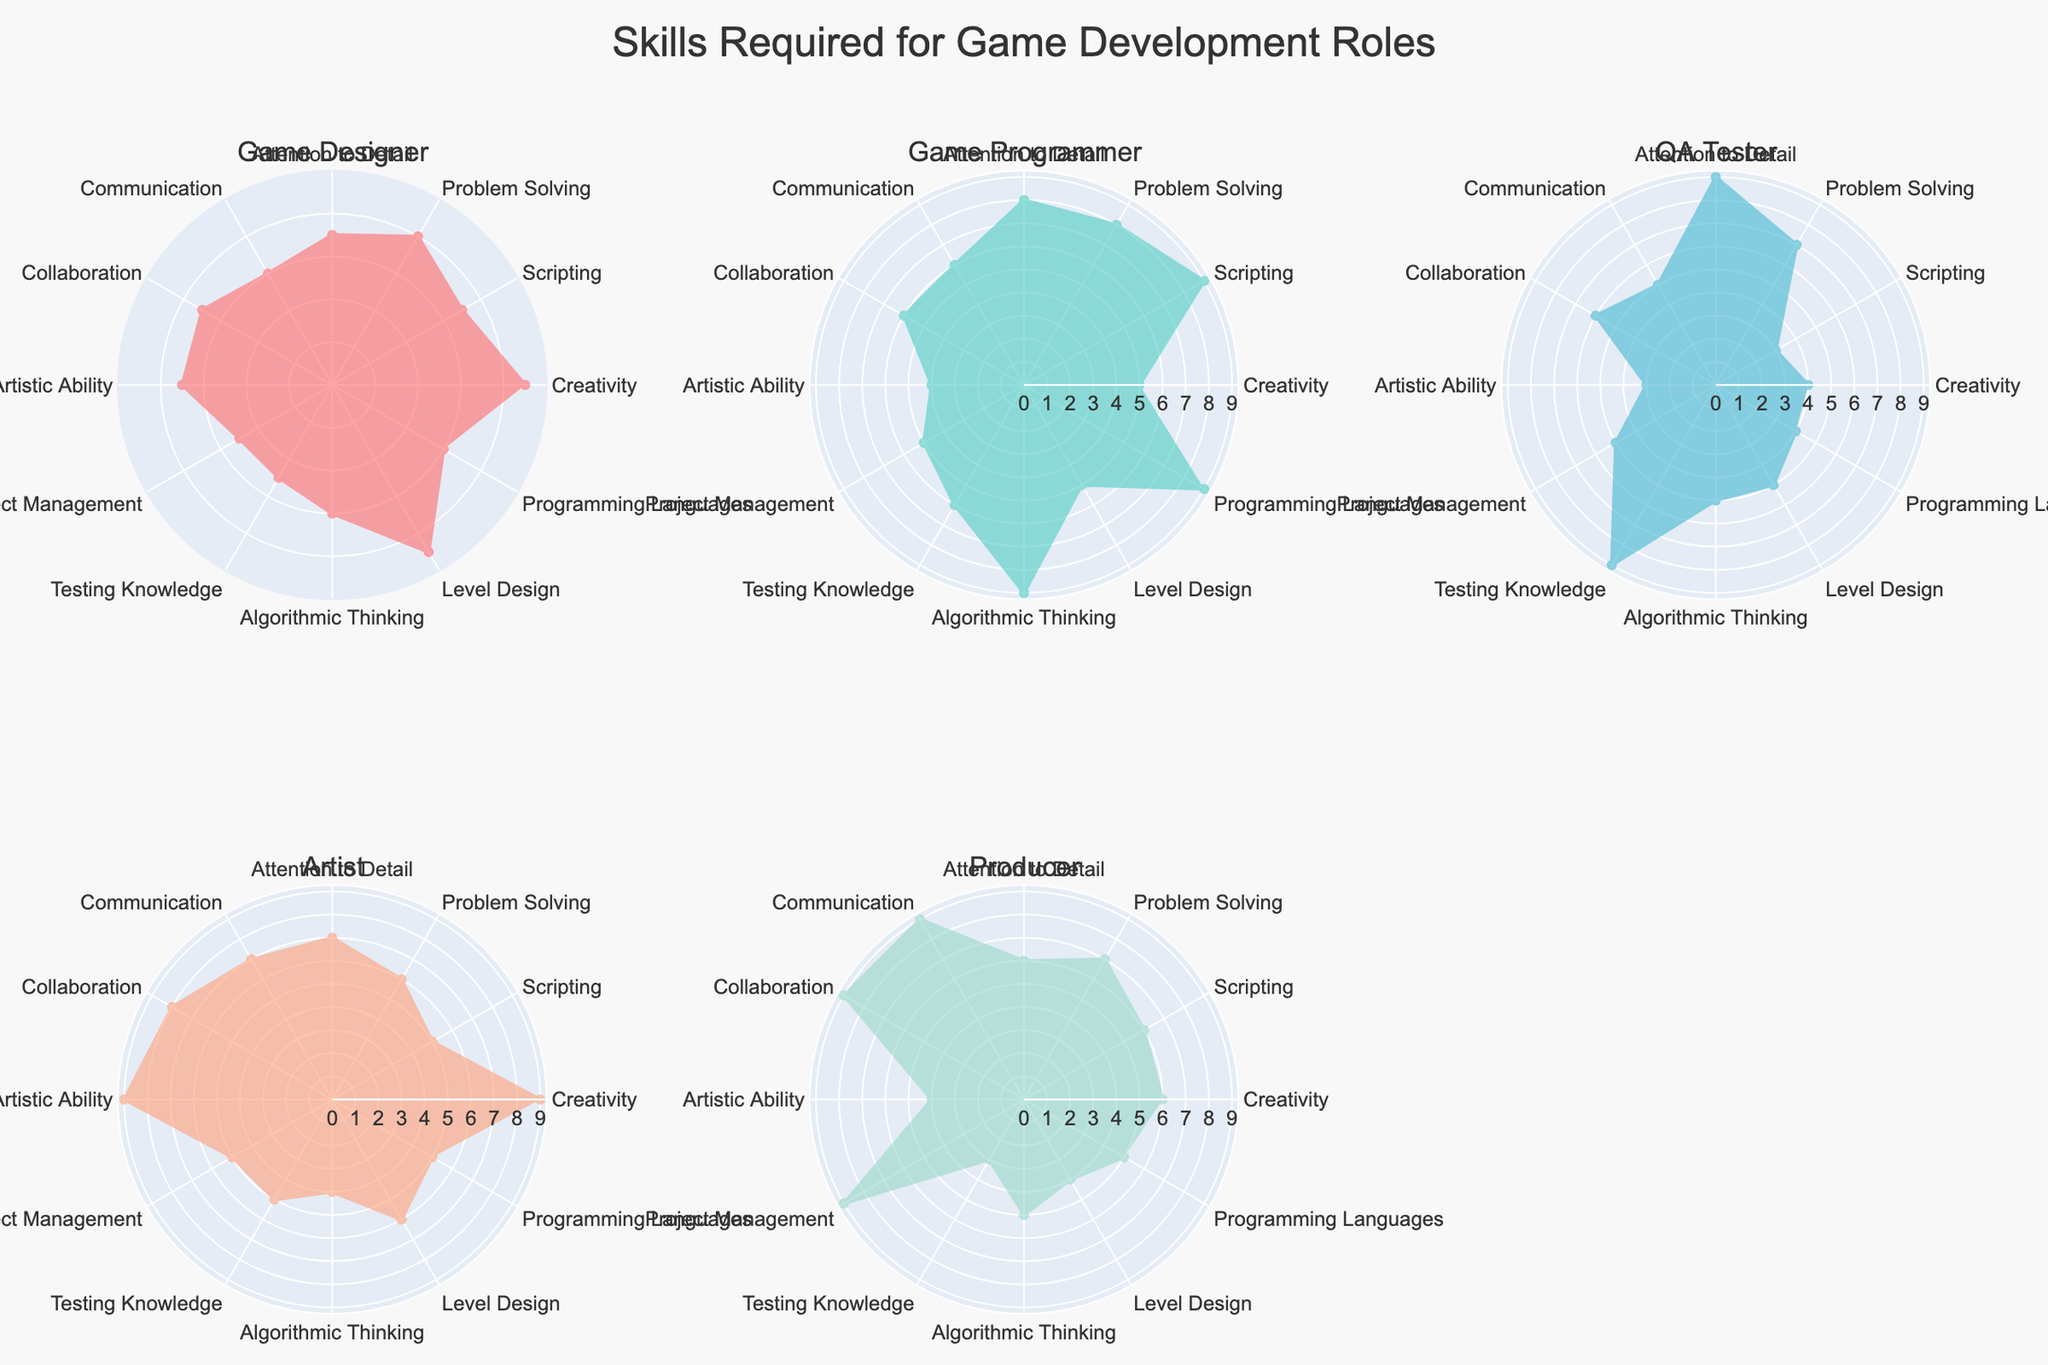What's the highest score for Creativity across all job roles? You look at the Creativity scores for each job role: 9 (Game Designer), 5 (Game Programmer), 4 (QA Tester), 9 (Artist), and 6 (Producer). The highest value is 9.
Answer: 9 Which job role has the highest score for Scripting? Examine the Scripting scores: 7 (Game Designer), 9 (Game Programmer), 3 (QA Tester), 5 (Artist), and 6 (Producer). The highest score is 9, which belongs to the Game Programmer.
Answer: Game Programmer Which skill does the QA Tester excel in the most? Check the scores for QA Tester in all skills: Creativity (4), Scripting (3), Problem Solving (7), Attention to Detail (9), Communication (5), Collaboration (6), Artistic Ability (3), Project Management (5), Testing Knowledge (9), Algorithmic Thinking (5), Level Design (5), Programming Languages (4). The maximum score is 9 for Attention to Detail and Testing Knowledge.
Answer: Attention to Detail and Testing Knowledge Compare the Communication skills between the Game Designer and the Producer. Who has the higher score? Look at the Communication scores: 6 (Game Designer) and 9 (Producer). The Producer has the higher score of 9.
Answer: Producer What's the average score for Problem Solving across all job roles? Sum the Problem Solving scores and divide by the number of roles: (8 + 8 + 7 + 6 + 7) = 36. Average = 36 / 5 = 7.2
Answer: 7.2 Identify the skill where the Artist has the lowest score. Examine the scores for the Artist: Creativity (9), Scripting (5), Problem Solving (6), Attention to Detail (7), Communication (7), Collaboration (8), Artistic Ability (9), Project Management (5), Testing Knowledge (5), Algorithmic Thinking (4), Level Design (6), Programming Languages (5). The lowest score is 4 for Algorithmic Thinking.
Answer: Algorithmic Thinking What are the top three skills for the Game Designer? Look at the scores for the Game Designer: Creativity (9), Scripting (7), Problem Solving (8), Attention to Detail (7), Communication (6), Collaboration (7), Artistic Ability (7), Project Management (5), Testing Knowledge (5), Algorithmic Thinking (6), Level Design (9), Programming Languages (6). The top three skills are Creativity (9), Level Design (9), and Problem Solving (8).
Answer: Creativity, Level Design, Problem Solving Which skill has the most similar scores across all job roles? Look at the scores for each skill across all roles and identify which one varies the least. This requires calculating the range (maximum - minimum) for each skill: 
Creativity (9-4=5), Scripting (9-3=6), Problem Solving (8-6=2), Attention to Detail (9-6=3), Communication (9-5=4), Collaboration (9-6=3), Artistic Ability (9-3=6), Project Management (9-5=4), Testing Knowledge (9-3=6), Algorithmic Thinking (9-4=5), Level Design (9-4=5), Programming Languages (9-4=5). The smallest range is 2 for Problem Solving.
Answer: Problem Solving How does the Producer score in Project Management compare to other roles? Compare Producer's Project Management score (9) with other roles: Game Designer (5), Game Programmer (5), QA Tester (5), Artist (5). The Producer's score is significantly higher.
Answer: Significantly higher 